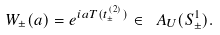Convert formula to latex. <formula><loc_0><loc_0><loc_500><loc_500>W _ { \pm } ( a ) = e ^ { i a T ( t ^ { ( 2 ) } _ { \pm } ) } \in \ A _ { U } ( S ^ { 1 } _ { \pm } ) .</formula> 